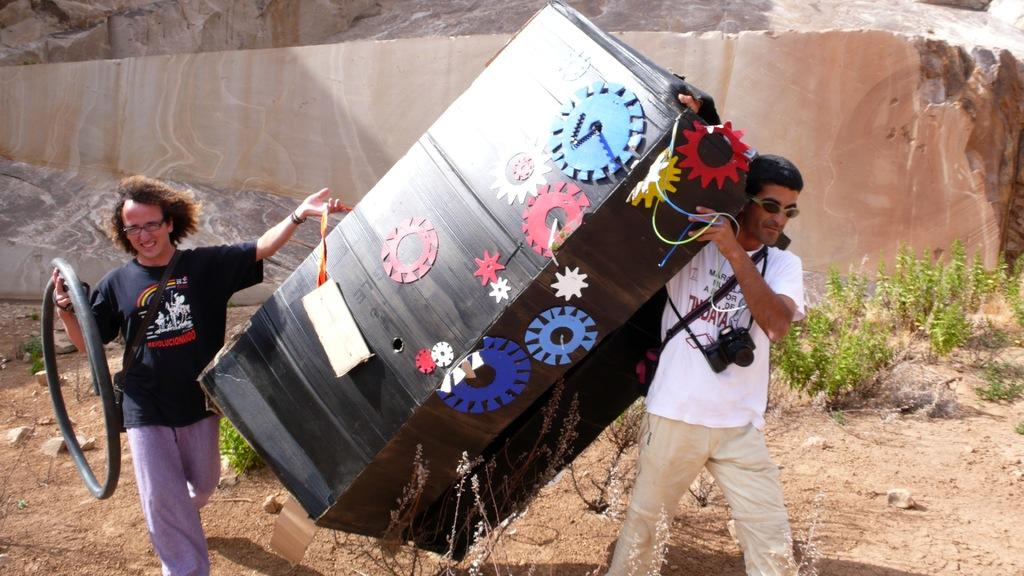How many people are in the image? There are people in the image, but the exact number is not specified. What are the people holding in the image? The people are holding objects in the image. What are the people wearing that are related to photography? The people are wearing cameras in the image. What can be seen in the background of the image? There is a rock and plants in the background of the image. What type of harmony can be heard in the image? There is no audible sound or music in the image, so it is not possible to determine the type of harmony present. 